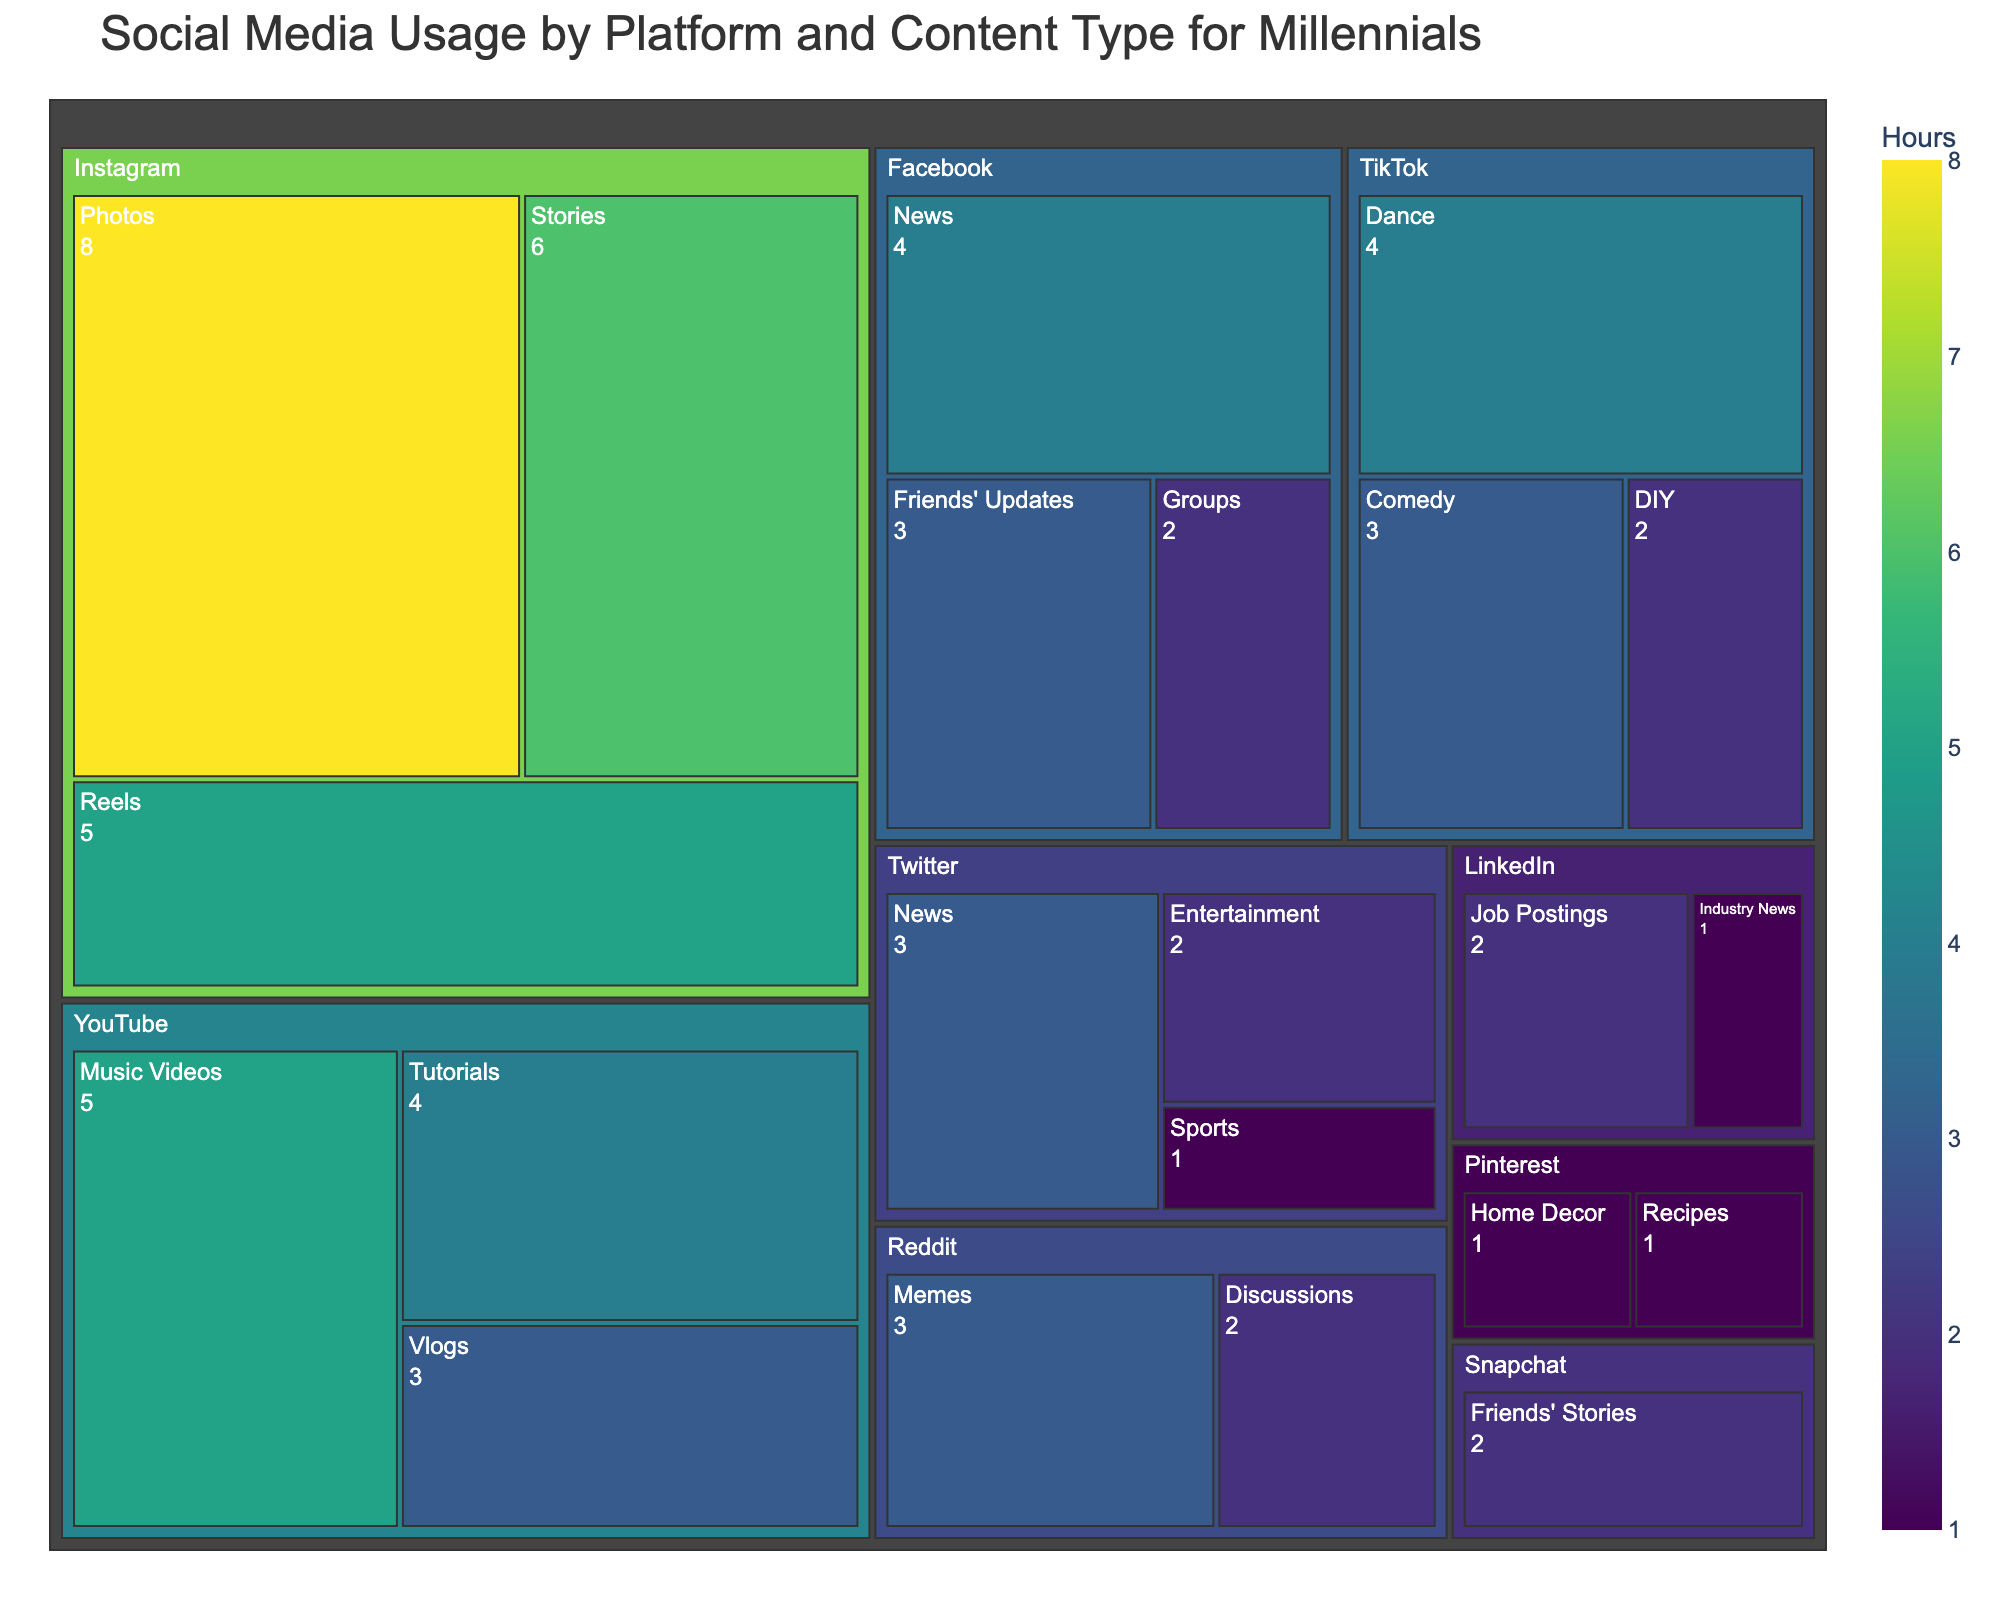what's the total time spent on TikTok? To find the total time spent on TikTok, sum the hours spent on each content type within the TikTok platform. TikTok involves Dance (4 hours), Comedy (3 hours), and DIY (2 hours). Adding these together results in 4 + 3 + 2 = 9 hours.
Answer: 9 hours Which content type on Instagram takes most of the user's time? For Instagram, compare the hours spent on each content type: Photos (8), Stories (6), and Reels (5). The highest value is 8 hours for Photos.
Answer: Photos How much more time is spent on Instagram Photos compared to Facebook News? Check the hours spent on Instagram Photos and Facebook News. Instagram Photos is 8 hours and Facebook News is 4 hours. The difference is 8 - 4 = 4 hours more.
Answer: 4 hours What's the total number of hours spent on content related to News? Identify all instances related to News: Facebook News (4 hours) and Twitter News (3 hours). Summing them together gives 4 + 3 = 7 hours.
Answer: 7 hours Between YouTube and TikTok, which platform has more usage time? Sum the hours for all content types per platform. For YouTube: Music Videos (5), Tutorials (4), Vlogs (3), total is 5 + 4 + 3 = 12 hours. For TikTok: Dance (4), Comedy (3), DIY (2), total is 4 + 3 + 2 = 9 hours. YouTube has 12 hours which is more than TikTok’s 9 hours.
Answer: YouTube Which has the least hours spent: Snapchat or Pinterest? Compare the hours for each platform. Snapchat has Friends' Stories (2 hours). Pinterest has Home Decor (1 hour) and Recipes (1 hour), total of 1 + 1 = 2 hours. Both have equal time spent of 2 hours each.
Answer: Equal What's the average time spent on Facebook per content type? Sum the hours for each content type under Facebook and divide by the number of content types. Facebook has News (4), Friends' Updates (3), and Groups (2), total is 4 + 3 + 2 = 9 hours. Divided by 3 types, the average is 9/3 = 3 hours per type.
Answer: 3 hours Which platform has the highest hours spent on a single content type? Compare the hours spent on the highest single content type across all platforms. Instagram Photos has 8 hours, which is the highest single content type.
Answer: Instagram Is the total time spent on Reels and Music Videos equal? Check the hours for each category: Instagram Reels (5 hours) and YouTube Music Videos (5 hours). Both have 5 hours each, so they are equal.
Answer: Yes Which has more usage time: Reddit Memes or LinkedIn Job Postings? Compare the hours for Reddit Memes and LinkedIn Job Postings. Reddit Memes is 3 hours, and LinkedIn Job Postings is 2 hours. Reddit Memes has more usage time.
Answer: Reddit Memes 